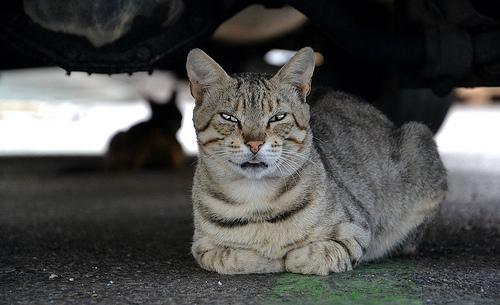How many cats are pictured?
Give a very brief answer. 2. How many ears can you see?
Give a very brief answer. 4. How many eyes are visible?
Give a very brief answer. 2. 